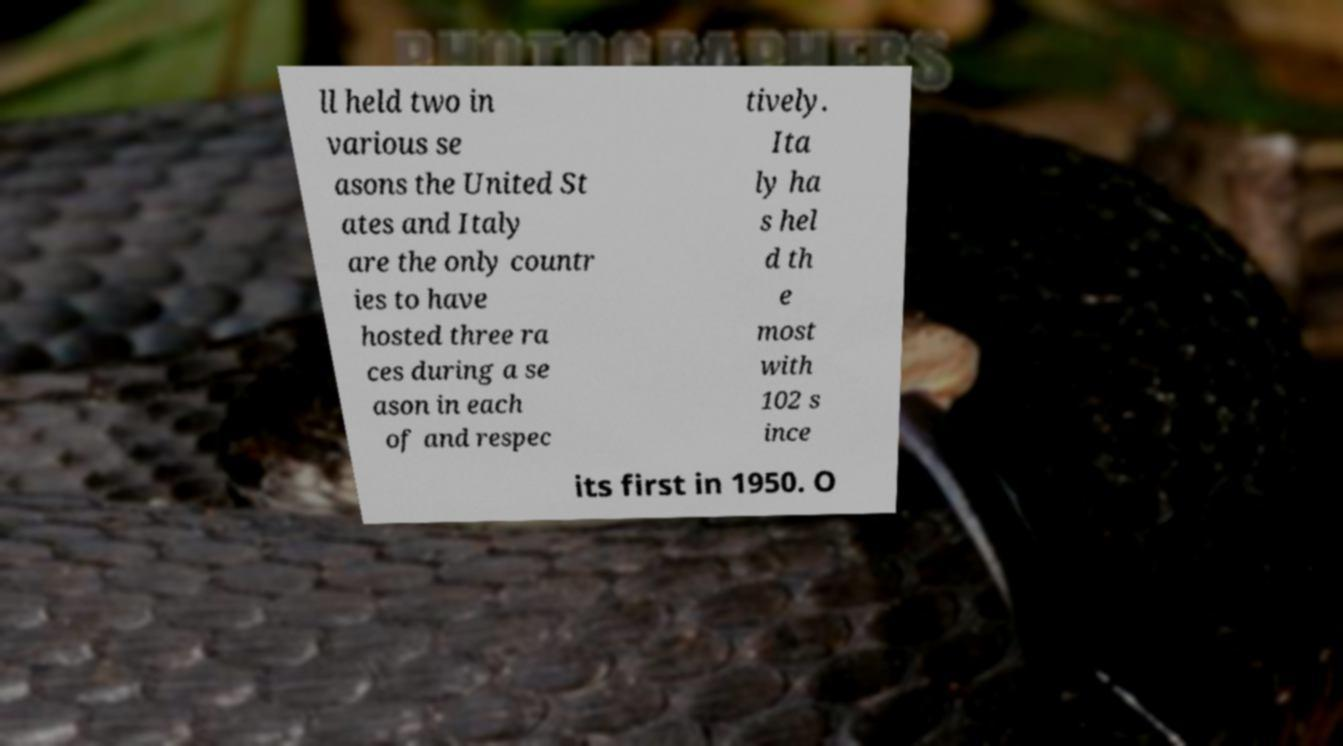Please identify and transcribe the text found in this image. ll held two in various se asons the United St ates and Italy are the only countr ies to have hosted three ra ces during a se ason in each of and respec tively. Ita ly ha s hel d th e most with 102 s ince its first in 1950. O 